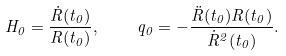<formula> <loc_0><loc_0><loc_500><loc_500>H _ { 0 } = \frac { { \dot { R } } ( t _ { 0 } ) } { R ( t _ { 0 } ) } , \quad q _ { 0 } = - \frac { { \ddot { R } } ( t _ { 0 } ) R ( t _ { 0 } ) } { { \dot { R } } ^ { 2 } ( t _ { 0 } ) } .</formula> 